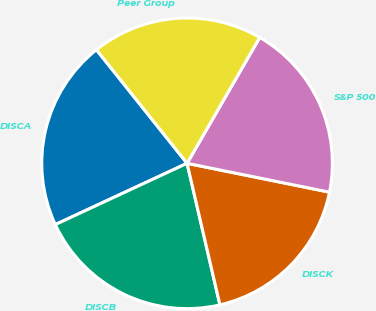Convert chart to OTSL. <chart><loc_0><loc_0><loc_500><loc_500><pie_chart><fcel>DISCA<fcel>DISCB<fcel>DISCK<fcel>S&P 500<fcel>Peer Group<nl><fcel>21.21%<fcel>21.7%<fcel>18.19%<fcel>19.85%<fcel>19.05%<nl></chart> 